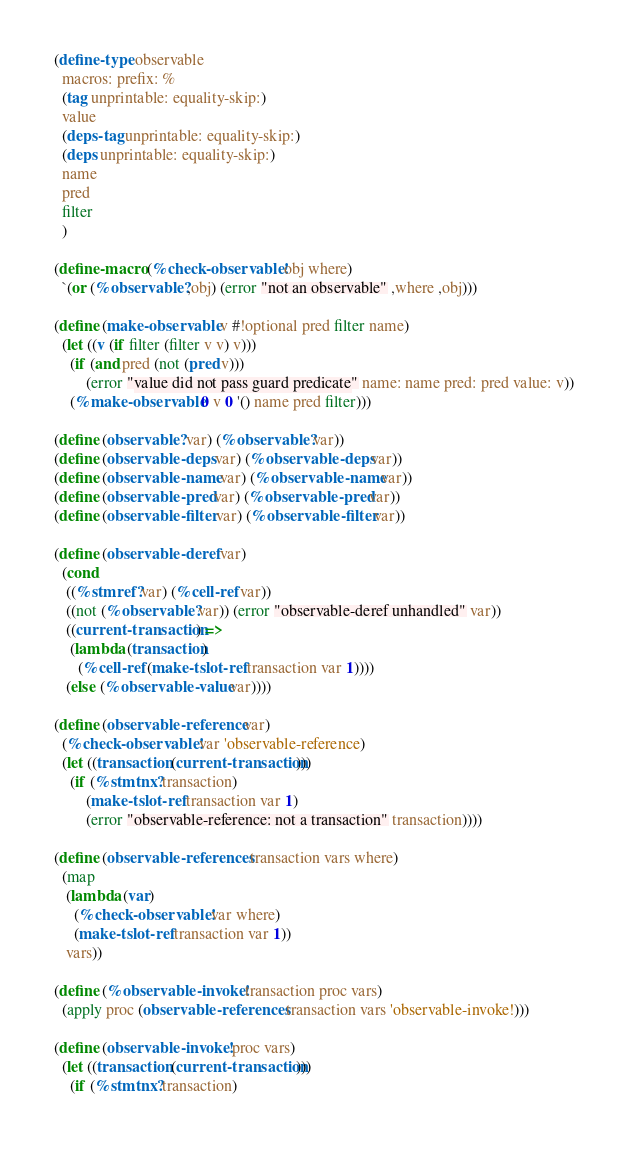<code> <loc_0><loc_0><loc_500><loc_500><_Scheme_>(define-type observable
  macros: prefix: %
  (tag unprintable: equality-skip:)
  value
  (deps-tag unprintable: equality-skip:)
  (deps unprintable: equality-skip:)
  name
  pred
  filter
  )

(define-macro (%check-observable! obj where)
  `(or (%observable? ,obj) (error "not an observable" ,where ,obj)))

(define (make-observable v #!optional pred filter name)
  (let ((v (if filter (filter v v) v)))
    (if (and pred (not (pred v)))
        (error "value did not pass guard predicate" name: name pred: pred value: v))
    (%make-observable 0 v 0 '() name pred filter)))

(define (observable? var) (%observable? var))
(define (observable-deps var) (%observable-deps var))
(define (observable-name var) (%observable-name var))
(define (observable-pred var) (%observable-pred var))
(define (observable-filter var) (%observable-filter var))

(define (observable-deref var)
  (cond
   ((%stmref? var) (%cell-ref var))
   ((not (%observable? var)) (error "observable-deref unhandled" var))
   ((current-transaction) =>
    (lambda (transaction)
      (%cell-ref (make-tslot-ref transaction var 1))))
   (else (%observable-value var))))

(define (observable-reference var)
  (%check-observable! var 'observable-reference)
  (let ((transaction (current-transaction)))
    (if (%stmtnx? transaction)
        (make-tslot-ref transaction var 1)
        (error "observable-reference: not a transaction" transaction))))

(define (observable-references transaction vars where)
  (map
   (lambda (var)
     (%check-observable! var where)
     (make-tslot-ref transaction var 1))
   vars))

(define (%observable-invoke! transaction proc vars)
  (apply proc (observable-references transaction vars 'observable-invoke!)))

(define (observable-invoke! proc vars)
  (let ((transaction (current-transaction)))
    (if (%stmtnx? transaction)</code> 